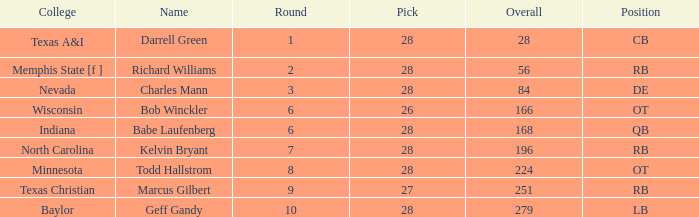What is the lowest round of the position de player with an overall less than 84? None. 